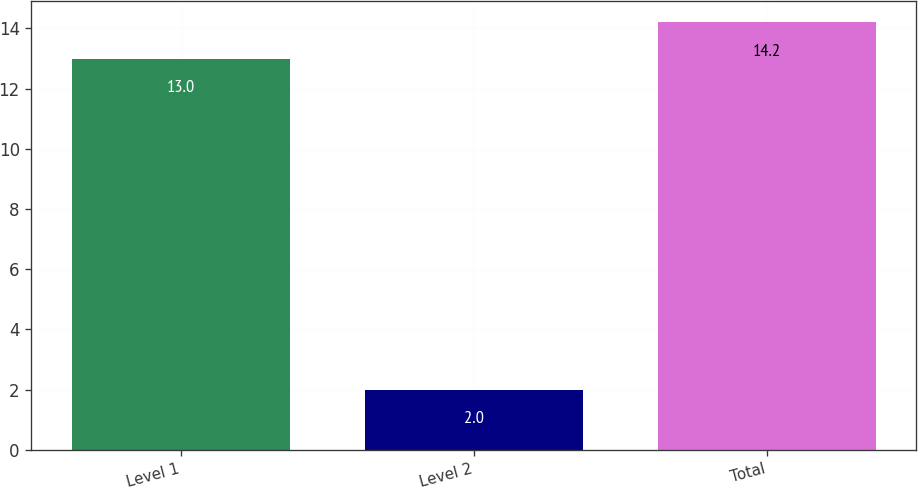Convert chart to OTSL. <chart><loc_0><loc_0><loc_500><loc_500><bar_chart><fcel>Level 1<fcel>Level 2<fcel>Total<nl><fcel>13<fcel>2<fcel>14.2<nl></chart> 